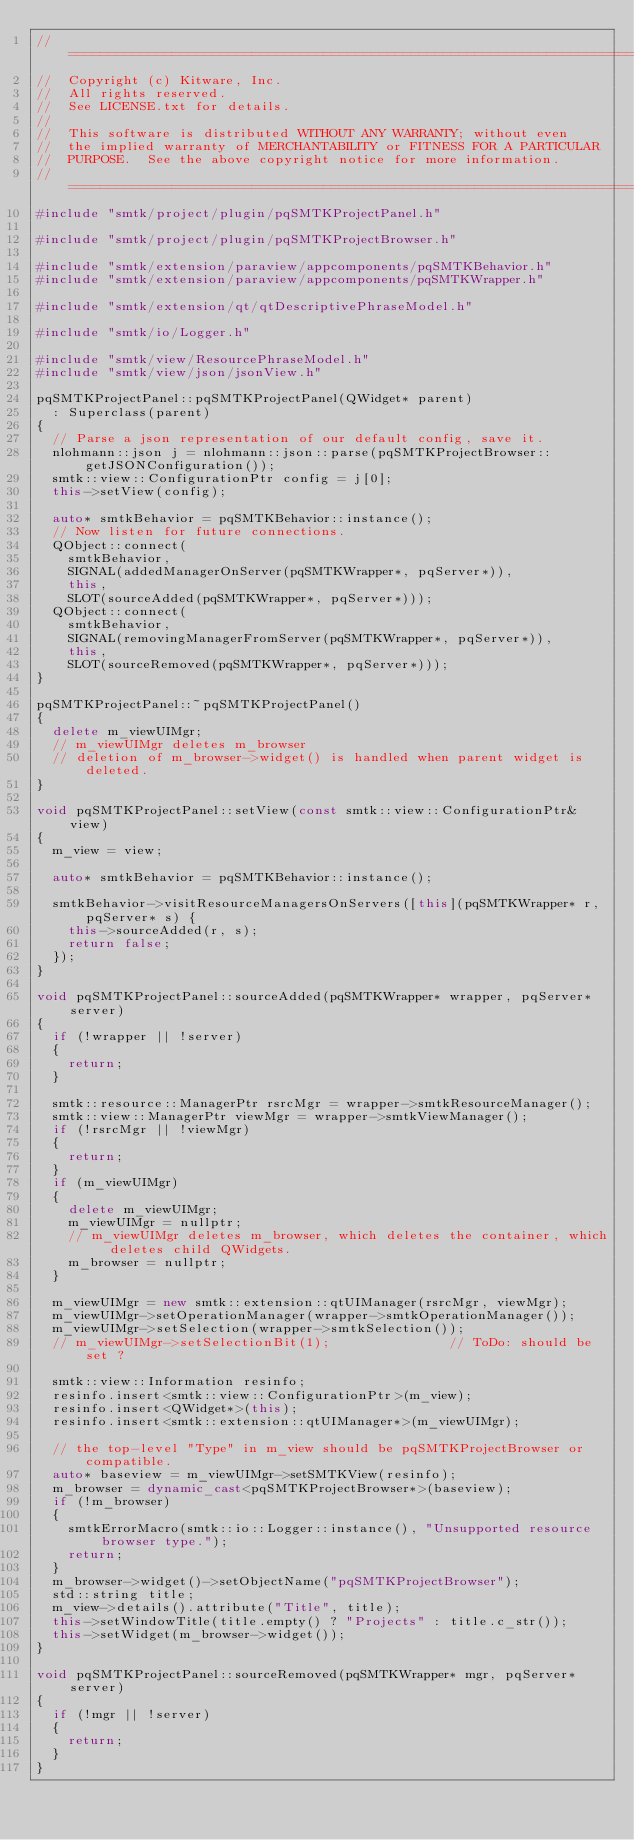<code> <loc_0><loc_0><loc_500><loc_500><_C++_>//=========================================================================
//  Copyright (c) Kitware, Inc.
//  All rights reserved.
//  See LICENSE.txt for details.
//
//  This software is distributed WITHOUT ANY WARRANTY; without even
//  the implied warranty of MERCHANTABILITY or FITNESS FOR A PARTICULAR
//  PURPOSE.  See the above copyright notice for more information.
//=========================================================================
#include "smtk/project/plugin/pqSMTKProjectPanel.h"

#include "smtk/project/plugin/pqSMTKProjectBrowser.h"

#include "smtk/extension/paraview/appcomponents/pqSMTKBehavior.h"
#include "smtk/extension/paraview/appcomponents/pqSMTKWrapper.h"

#include "smtk/extension/qt/qtDescriptivePhraseModel.h"

#include "smtk/io/Logger.h"

#include "smtk/view/ResourcePhraseModel.h"
#include "smtk/view/json/jsonView.h"

pqSMTKProjectPanel::pqSMTKProjectPanel(QWidget* parent)
  : Superclass(parent)
{
  // Parse a json representation of our default config, save it.
  nlohmann::json j = nlohmann::json::parse(pqSMTKProjectBrowser::getJSONConfiguration());
  smtk::view::ConfigurationPtr config = j[0];
  this->setView(config);

  auto* smtkBehavior = pqSMTKBehavior::instance();
  // Now listen for future connections.
  QObject::connect(
    smtkBehavior,
    SIGNAL(addedManagerOnServer(pqSMTKWrapper*, pqServer*)),
    this,
    SLOT(sourceAdded(pqSMTKWrapper*, pqServer*)));
  QObject::connect(
    smtkBehavior,
    SIGNAL(removingManagerFromServer(pqSMTKWrapper*, pqServer*)),
    this,
    SLOT(sourceRemoved(pqSMTKWrapper*, pqServer*)));
}

pqSMTKProjectPanel::~pqSMTKProjectPanel()
{
  delete m_viewUIMgr;
  // m_viewUIMgr deletes m_browser
  // deletion of m_browser->widget() is handled when parent widget is deleted.
}

void pqSMTKProjectPanel::setView(const smtk::view::ConfigurationPtr& view)
{
  m_view = view;

  auto* smtkBehavior = pqSMTKBehavior::instance();

  smtkBehavior->visitResourceManagersOnServers([this](pqSMTKWrapper* r, pqServer* s) {
    this->sourceAdded(r, s);
    return false;
  });
}

void pqSMTKProjectPanel::sourceAdded(pqSMTKWrapper* wrapper, pqServer* server)
{
  if (!wrapper || !server)
  {
    return;
  }

  smtk::resource::ManagerPtr rsrcMgr = wrapper->smtkResourceManager();
  smtk::view::ManagerPtr viewMgr = wrapper->smtkViewManager();
  if (!rsrcMgr || !viewMgr)
  {
    return;
  }
  if (m_viewUIMgr)
  {
    delete m_viewUIMgr;
    m_viewUIMgr = nullptr;
    // m_viewUIMgr deletes m_browser, which deletes the container, which deletes child QWidgets.
    m_browser = nullptr;
  }

  m_viewUIMgr = new smtk::extension::qtUIManager(rsrcMgr, viewMgr);
  m_viewUIMgr->setOperationManager(wrapper->smtkOperationManager());
  m_viewUIMgr->setSelection(wrapper->smtkSelection());
  // m_viewUIMgr->setSelectionBit(1);               // ToDo: should be set ?

  smtk::view::Information resinfo;
  resinfo.insert<smtk::view::ConfigurationPtr>(m_view);
  resinfo.insert<QWidget*>(this);
  resinfo.insert<smtk::extension::qtUIManager*>(m_viewUIMgr);

  // the top-level "Type" in m_view should be pqSMTKProjectBrowser or compatible.
  auto* baseview = m_viewUIMgr->setSMTKView(resinfo);
  m_browser = dynamic_cast<pqSMTKProjectBrowser*>(baseview);
  if (!m_browser)
  {
    smtkErrorMacro(smtk::io::Logger::instance(), "Unsupported resource browser type.");
    return;
  }
  m_browser->widget()->setObjectName("pqSMTKProjectBrowser");
  std::string title;
  m_view->details().attribute("Title", title);
  this->setWindowTitle(title.empty() ? "Projects" : title.c_str());
  this->setWidget(m_browser->widget());
}

void pqSMTKProjectPanel::sourceRemoved(pqSMTKWrapper* mgr, pqServer* server)
{
  if (!mgr || !server)
  {
    return;
  }
}
</code> 